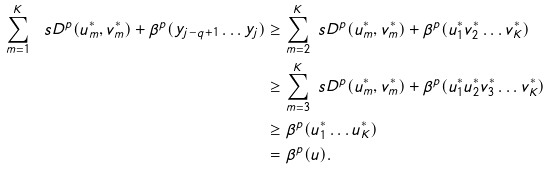<formula> <loc_0><loc_0><loc_500><loc_500>\sum _ { m = 1 } ^ { K } \ s D ^ { p } ( u ^ { * } _ { m } , v ^ { * } _ { m } ) + \beta ^ { p } ( y _ { j - q + 1 } \dots y _ { j } ) & \geq \sum _ { m = 2 } ^ { K } \ s D ^ { p } ( u ^ { * } _ { m } , v ^ { * } _ { m } ) + \beta ^ { p } ( u ^ { * } _ { 1 } v ^ { * } _ { 2 } \dots v ^ { * } _ { K } ) \\ & \geq \sum _ { m = 3 } ^ { K } \ s D ^ { p } ( u ^ { * } _ { m } , v ^ { * } _ { m } ) + \beta ^ { p } ( u ^ { * } _ { 1 } u ^ { * } _ { 2 } v ^ { * } _ { 3 } \dots v ^ { * } _ { K } ) \\ & \geq \beta ^ { p } ( u ^ { * } _ { 1 } \dots u ^ { * } _ { K } ) \\ & = \beta ^ { p } ( u ) .</formula> 